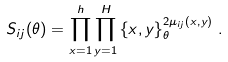Convert formula to latex. <formula><loc_0><loc_0><loc_500><loc_500>S _ { i j } ( \theta ) = \prod _ { x = 1 } ^ { h } \prod _ { y = 1 } ^ { H } \left \{ x , y \right \} _ { \theta } ^ { 2 \mu _ { i j } ( x , y ) } \, .</formula> 